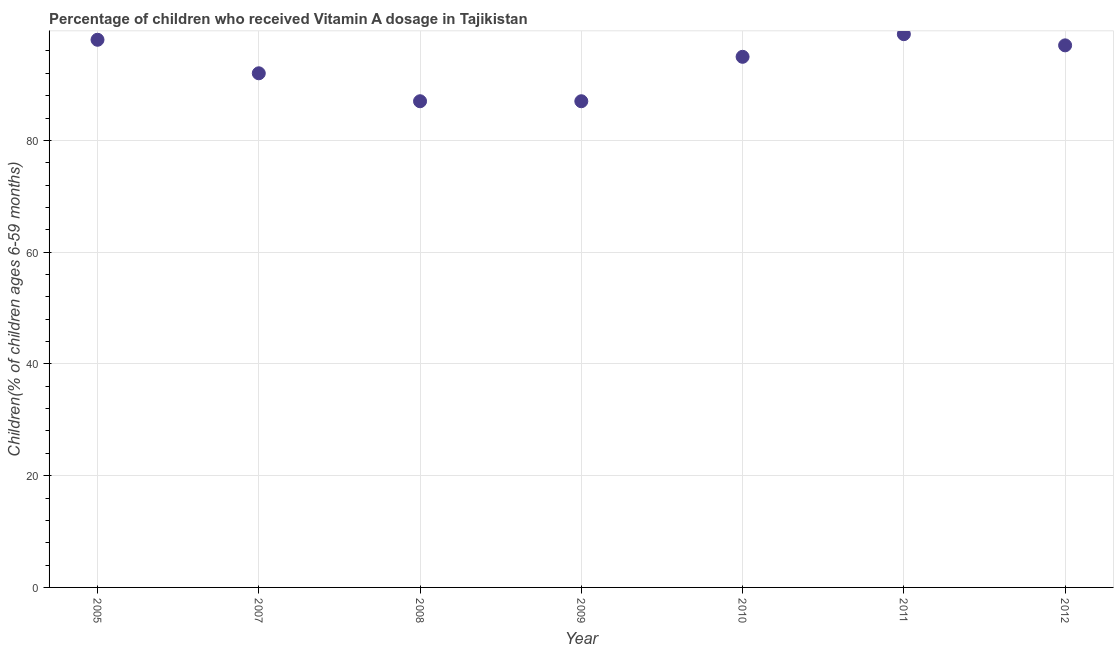What is the vitamin a supplementation coverage rate in 2012?
Keep it short and to the point. 97. Across all years, what is the minimum vitamin a supplementation coverage rate?
Your answer should be compact. 87. In which year was the vitamin a supplementation coverage rate maximum?
Make the answer very short. 2011. In which year was the vitamin a supplementation coverage rate minimum?
Your response must be concise. 2008. What is the sum of the vitamin a supplementation coverage rate?
Your answer should be compact. 654.95. What is the difference between the vitamin a supplementation coverage rate in 2011 and 2012?
Keep it short and to the point. 2. What is the average vitamin a supplementation coverage rate per year?
Your response must be concise. 93.56. What is the median vitamin a supplementation coverage rate?
Ensure brevity in your answer.  94.95. In how many years, is the vitamin a supplementation coverage rate greater than 24 %?
Ensure brevity in your answer.  7. What is the ratio of the vitamin a supplementation coverage rate in 2005 to that in 2011?
Provide a succinct answer. 0.99. Is the vitamin a supplementation coverage rate in 2009 less than that in 2012?
Offer a terse response. Yes. Is the difference between the vitamin a supplementation coverage rate in 2009 and 2012 greater than the difference between any two years?
Offer a terse response. No. What is the difference between the highest and the lowest vitamin a supplementation coverage rate?
Offer a terse response. 12. In how many years, is the vitamin a supplementation coverage rate greater than the average vitamin a supplementation coverage rate taken over all years?
Make the answer very short. 4. How many years are there in the graph?
Offer a very short reply. 7. What is the difference between two consecutive major ticks on the Y-axis?
Keep it short and to the point. 20. Are the values on the major ticks of Y-axis written in scientific E-notation?
Provide a succinct answer. No. Does the graph contain grids?
Make the answer very short. Yes. What is the title of the graph?
Your answer should be compact. Percentage of children who received Vitamin A dosage in Tajikistan. What is the label or title of the X-axis?
Offer a terse response. Year. What is the label or title of the Y-axis?
Ensure brevity in your answer.  Children(% of children ages 6-59 months). What is the Children(% of children ages 6-59 months) in 2005?
Ensure brevity in your answer.  98. What is the Children(% of children ages 6-59 months) in 2007?
Your answer should be compact. 92. What is the Children(% of children ages 6-59 months) in 2008?
Make the answer very short. 87. What is the Children(% of children ages 6-59 months) in 2009?
Provide a short and direct response. 87. What is the Children(% of children ages 6-59 months) in 2010?
Offer a very short reply. 94.95. What is the Children(% of children ages 6-59 months) in 2012?
Ensure brevity in your answer.  97. What is the difference between the Children(% of children ages 6-59 months) in 2005 and 2010?
Ensure brevity in your answer.  3.05. What is the difference between the Children(% of children ages 6-59 months) in 2005 and 2011?
Provide a succinct answer. -1. What is the difference between the Children(% of children ages 6-59 months) in 2005 and 2012?
Your answer should be very brief. 1. What is the difference between the Children(% of children ages 6-59 months) in 2007 and 2008?
Make the answer very short. 5. What is the difference between the Children(% of children ages 6-59 months) in 2007 and 2009?
Keep it short and to the point. 5. What is the difference between the Children(% of children ages 6-59 months) in 2007 and 2010?
Keep it short and to the point. -2.95. What is the difference between the Children(% of children ages 6-59 months) in 2007 and 2011?
Ensure brevity in your answer.  -7. What is the difference between the Children(% of children ages 6-59 months) in 2007 and 2012?
Make the answer very short. -5. What is the difference between the Children(% of children ages 6-59 months) in 2008 and 2010?
Your answer should be compact. -7.95. What is the difference between the Children(% of children ages 6-59 months) in 2008 and 2011?
Offer a very short reply. -12. What is the difference between the Children(% of children ages 6-59 months) in 2008 and 2012?
Provide a succinct answer. -10. What is the difference between the Children(% of children ages 6-59 months) in 2009 and 2010?
Keep it short and to the point. -7.95. What is the difference between the Children(% of children ages 6-59 months) in 2010 and 2011?
Ensure brevity in your answer.  -4.05. What is the difference between the Children(% of children ages 6-59 months) in 2010 and 2012?
Keep it short and to the point. -2.05. What is the difference between the Children(% of children ages 6-59 months) in 2011 and 2012?
Your answer should be very brief. 2. What is the ratio of the Children(% of children ages 6-59 months) in 2005 to that in 2007?
Make the answer very short. 1.06. What is the ratio of the Children(% of children ages 6-59 months) in 2005 to that in 2008?
Your answer should be very brief. 1.13. What is the ratio of the Children(% of children ages 6-59 months) in 2005 to that in 2009?
Your answer should be compact. 1.13. What is the ratio of the Children(% of children ages 6-59 months) in 2005 to that in 2010?
Ensure brevity in your answer.  1.03. What is the ratio of the Children(% of children ages 6-59 months) in 2005 to that in 2011?
Your response must be concise. 0.99. What is the ratio of the Children(% of children ages 6-59 months) in 2007 to that in 2008?
Keep it short and to the point. 1.06. What is the ratio of the Children(% of children ages 6-59 months) in 2007 to that in 2009?
Make the answer very short. 1.06. What is the ratio of the Children(% of children ages 6-59 months) in 2007 to that in 2011?
Offer a very short reply. 0.93. What is the ratio of the Children(% of children ages 6-59 months) in 2007 to that in 2012?
Ensure brevity in your answer.  0.95. What is the ratio of the Children(% of children ages 6-59 months) in 2008 to that in 2010?
Your response must be concise. 0.92. What is the ratio of the Children(% of children ages 6-59 months) in 2008 to that in 2011?
Keep it short and to the point. 0.88. What is the ratio of the Children(% of children ages 6-59 months) in 2008 to that in 2012?
Your answer should be very brief. 0.9. What is the ratio of the Children(% of children ages 6-59 months) in 2009 to that in 2010?
Provide a succinct answer. 0.92. What is the ratio of the Children(% of children ages 6-59 months) in 2009 to that in 2011?
Offer a very short reply. 0.88. What is the ratio of the Children(% of children ages 6-59 months) in 2009 to that in 2012?
Ensure brevity in your answer.  0.9. 